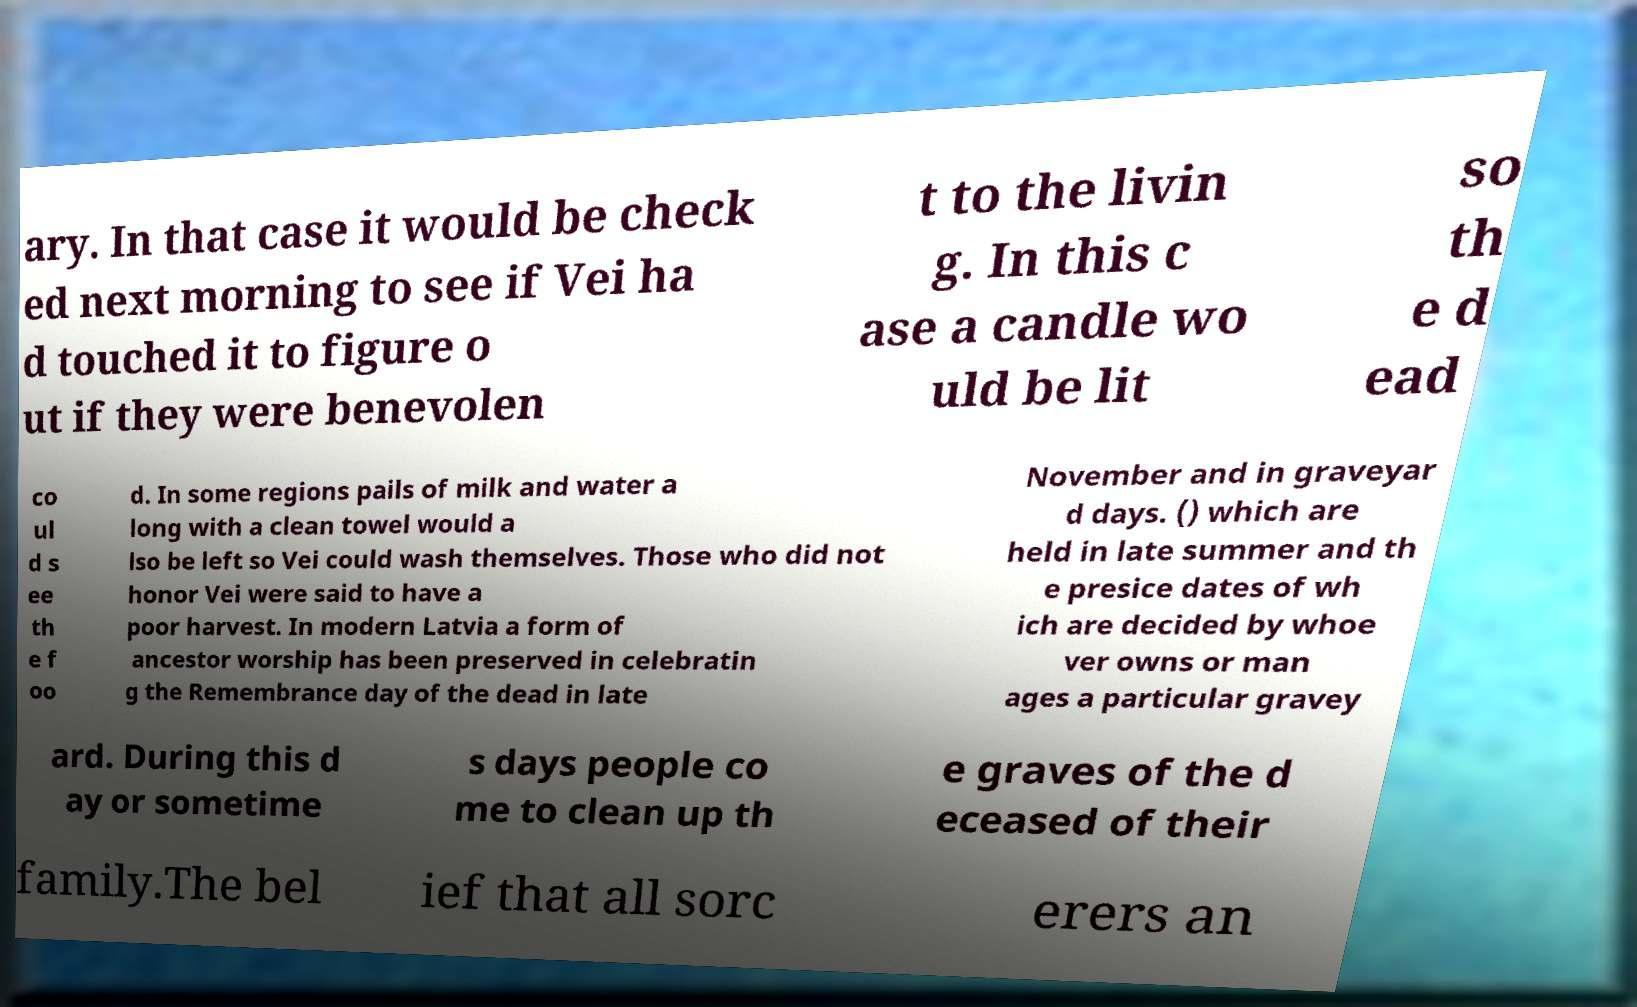For documentation purposes, I need the text within this image transcribed. Could you provide that? ary. In that case it would be check ed next morning to see if Vei ha d touched it to figure o ut if they were benevolen t to the livin g. In this c ase a candle wo uld be lit so th e d ead co ul d s ee th e f oo d. In some regions pails of milk and water a long with a clean towel would a lso be left so Vei could wash themselves. Those who did not honor Vei were said to have a poor harvest. In modern Latvia a form of ancestor worship has been preserved in celebratin g the Remembrance day of the dead in late November and in graveyar d days. () which are held in late summer and th e presice dates of wh ich are decided by whoe ver owns or man ages a particular gravey ard. During this d ay or sometime s days people co me to clean up th e graves of the d eceased of their family.The bel ief that all sorc erers an 